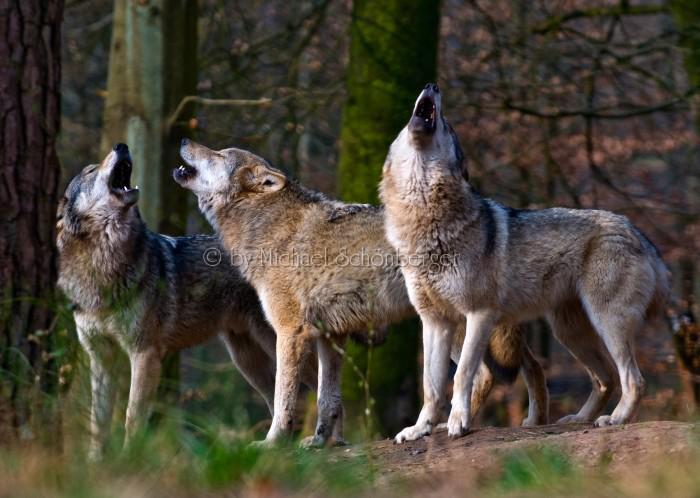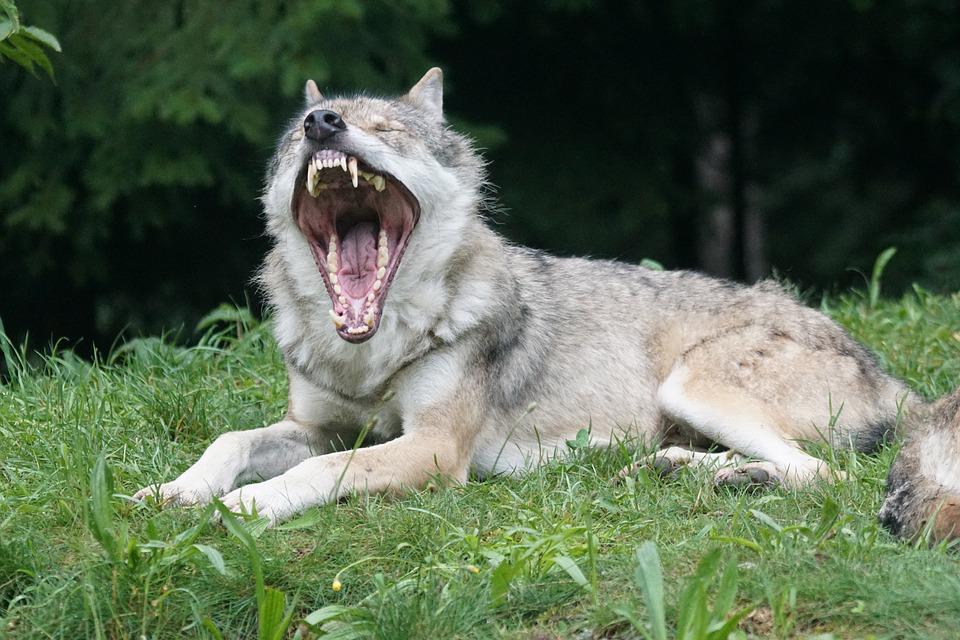The first image is the image on the left, the second image is the image on the right. Considering the images on both sides, is "The right image contains exactly one wolf." valid? Answer yes or no. Yes. The first image is the image on the left, the second image is the image on the right. Given the left and right images, does the statement "An image contains exactly four wolves posed similarly and side-by-side." hold true? Answer yes or no. No. 